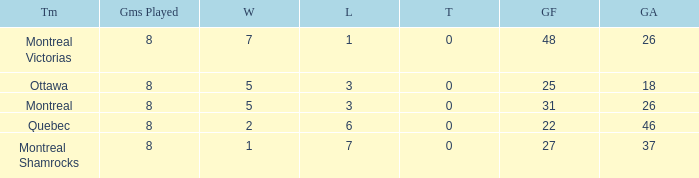How many losses did the team with 22 goals for andmore than 8 games played have? 0.0. 